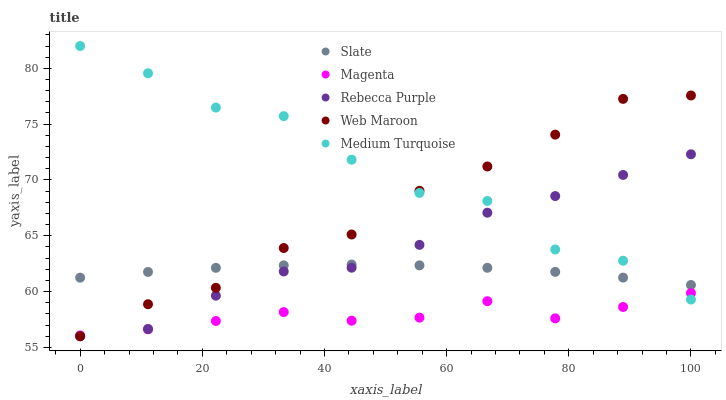Does Magenta have the minimum area under the curve?
Answer yes or no. Yes. Does Medium Turquoise have the maximum area under the curve?
Answer yes or no. Yes. Does Web Maroon have the minimum area under the curve?
Answer yes or no. No. Does Web Maroon have the maximum area under the curve?
Answer yes or no. No. Is Slate the smoothest?
Answer yes or no. Yes. Is Medium Turquoise the roughest?
Answer yes or no. Yes. Is Web Maroon the smoothest?
Answer yes or no. No. Is Web Maroon the roughest?
Answer yes or no. No. Does Web Maroon have the lowest value?
Answer yes or no. Yes. Does Magenta have the lowest value?
Answer yes or no. No. Does Medium Turquoise have the highest value?
Answer yes or no. Yes. Does Web Maroon have the highest value?
Answer yes or no. No. Is Magenta less than Slate?
Answer yes or no. Yes. Is Slate greater than Magenta?
Answer yes or no. Yes. Does Slate intersect Rebecca Purple?
Answer yes or no. Yes. Is Slate less than Rebecca Purple?
Answer yes or no. No. Is Slate greater than Rebecca Purple?
Answer yes or no. No. Does Magenta intersect Slate?
Answer yes or no. No. 